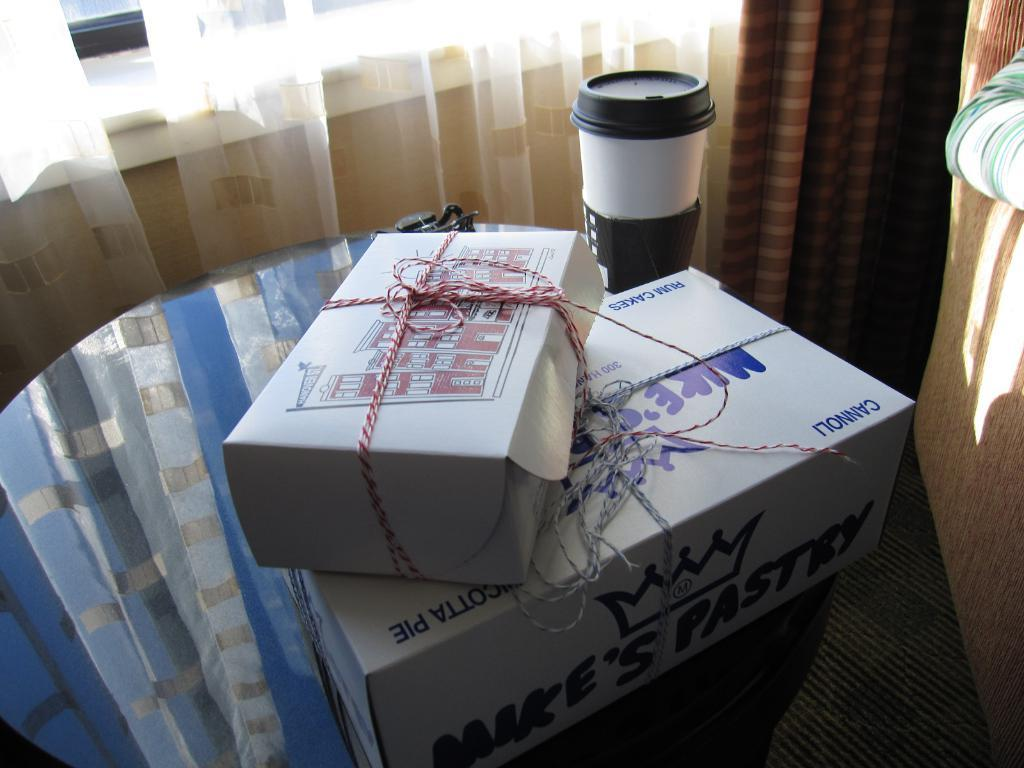<image>
Render a clear and concise summary of the photo. Two boxes are stacked, one of which contains cannoli. 